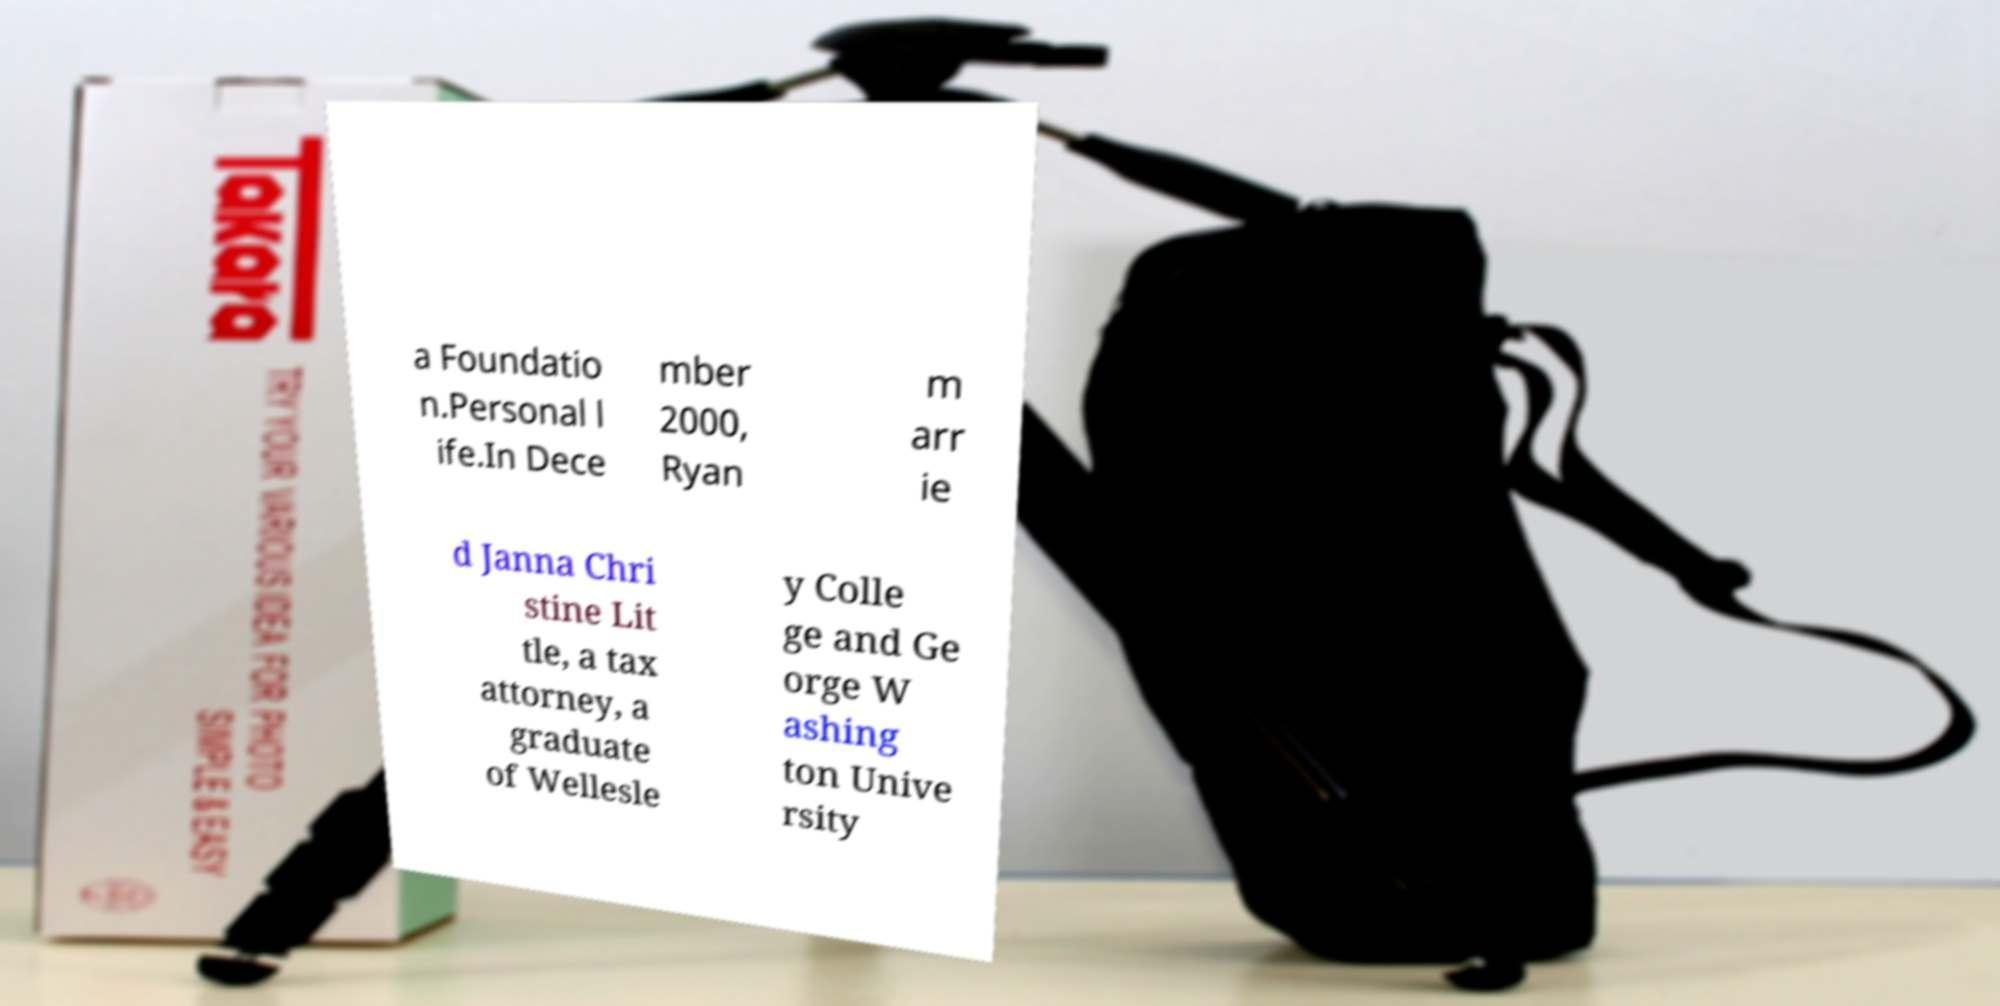Please identify and transcribe the text found in this image. a Foundatio n.Personal l ife.In Dece mber 2000, Ryan m arr ie d Janna Chri stine Lit tle, a tax attorney, a graduate of Wellesle y Colle ge and Ge orge W ashing ton Unive rsity 